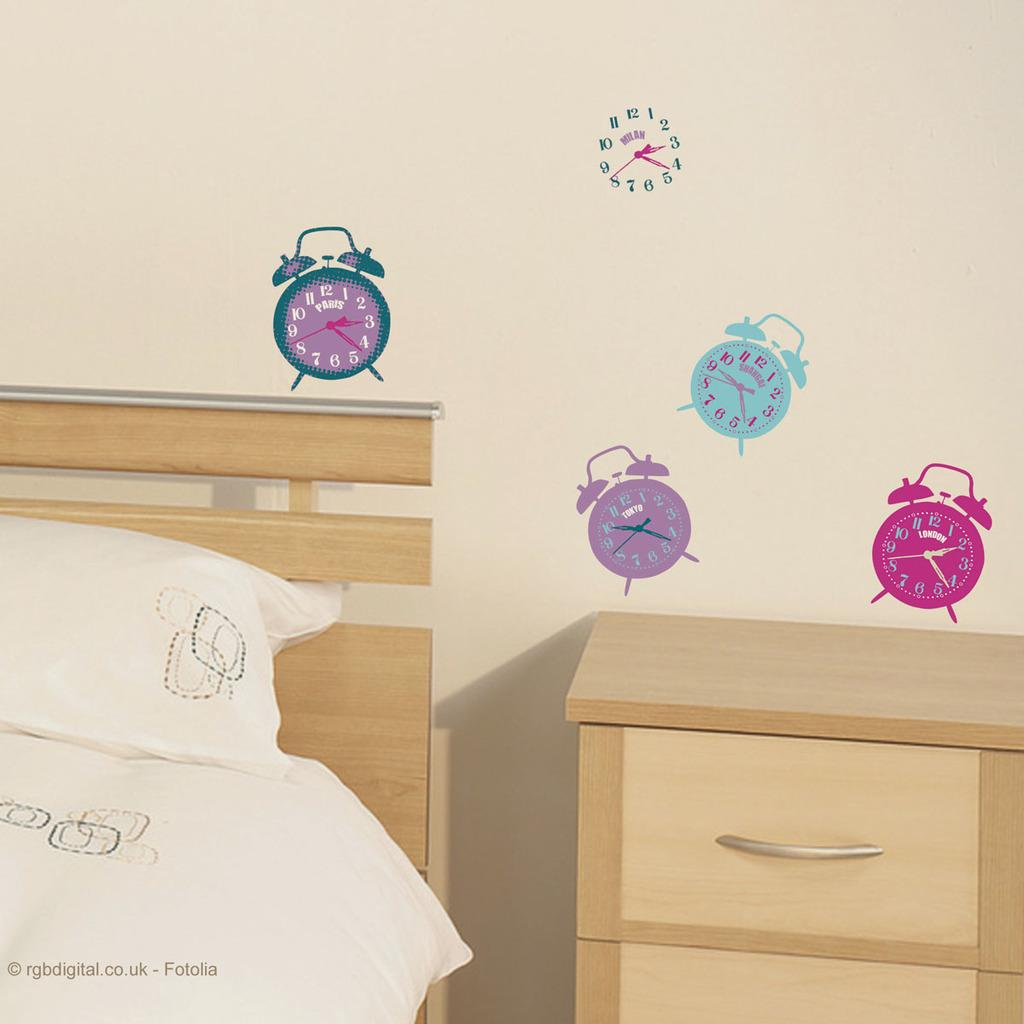<image>
Write a terse but informative summary of the picture. The clock pictures on the wall all read different times. 